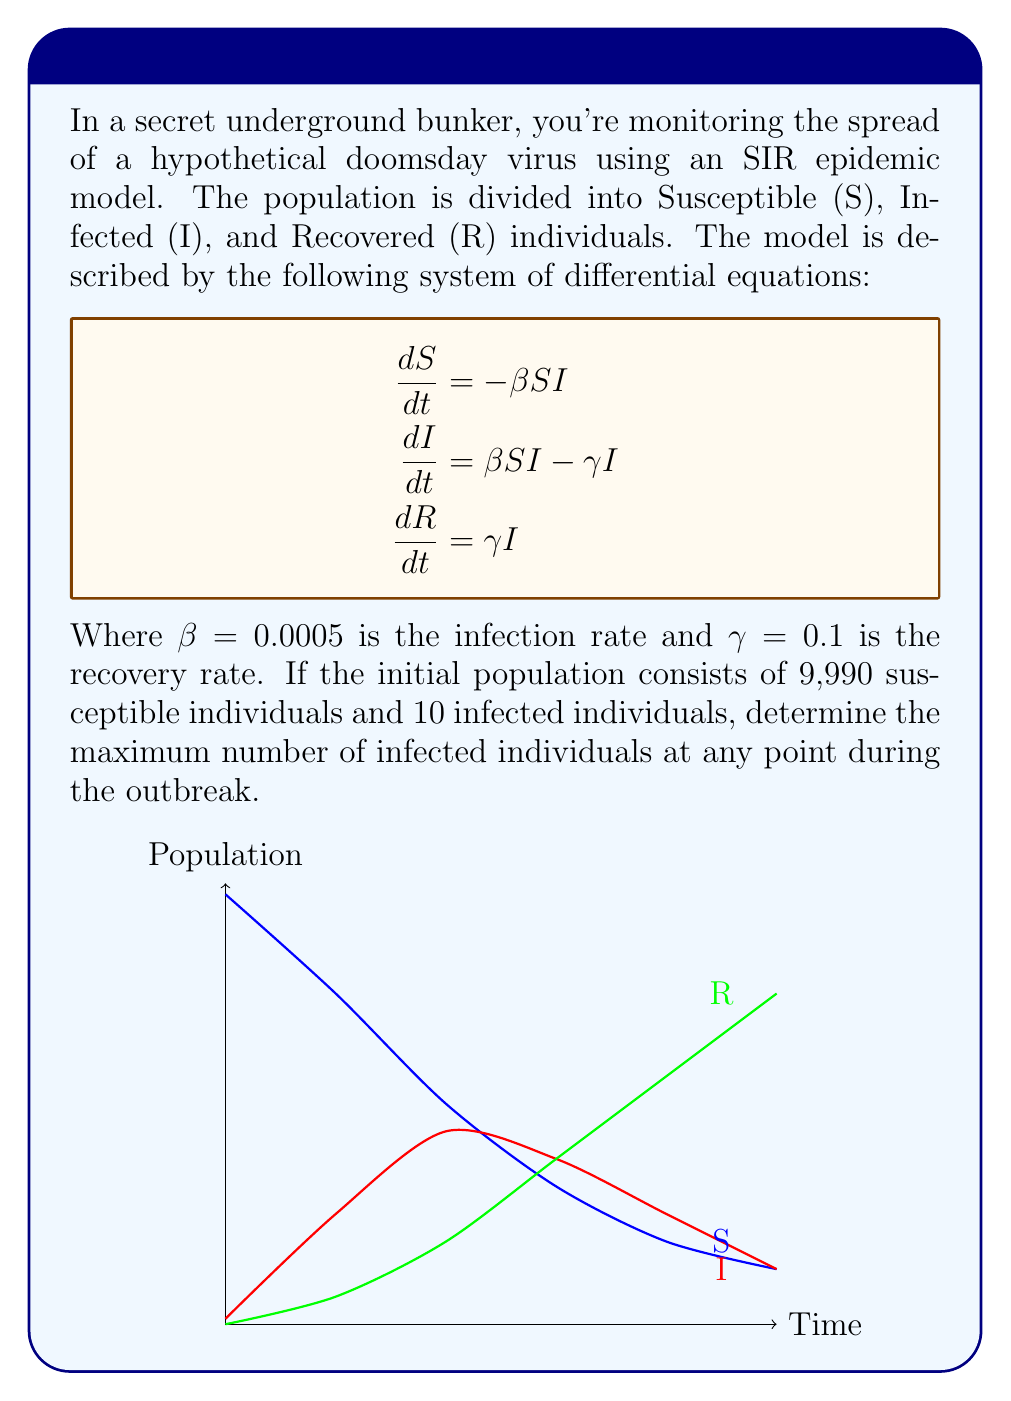What is the answer to this math problem? To find the maximum number of infected individuals, we need to determine when $\frac{dI}{dt} = 0$. This occurs when the rate of new infections equals the rate of recoveries.

Step 1: Set $\frac{dI}{dt} = 0$
$$\beta SI - \gamma I = 0$$

Step 2: Factor out I
$$I(\beta S - \gamma) = 0$$

Step 3: Solve for S when I ≠ 0
$$S = \frac{\gamma}{\beta} = \frac{0.1}{0.0005} = 200$$

Step 4: Use the conservation of population equation
$$N = S + I + R = 10000$$

Step 5: Calculate R using the SIR model equations
$$\frac{dR}{dS} = -\frac{\gamma}{\beta S}$$
Integrating both sides:
$$R - R_0 = -\frac{\gamma}{\beta} \ln(\frac{S}{S_0})$$
$$R = \frac{\gamma}{\beta} \ln(\frac{S_0}{S}) = 200 \ln(\frac{9990}{200}) \approx 7980$$

Step 6: Calculate the maximum number of infected individuals
$$I_{max} = N - S - R = 10000 - 200 - 7980 = 1820$$

Therefore, the maximum number of infected individuals during the outbreak is approximately 1,820.
Answer: 1,820 infected individuals 